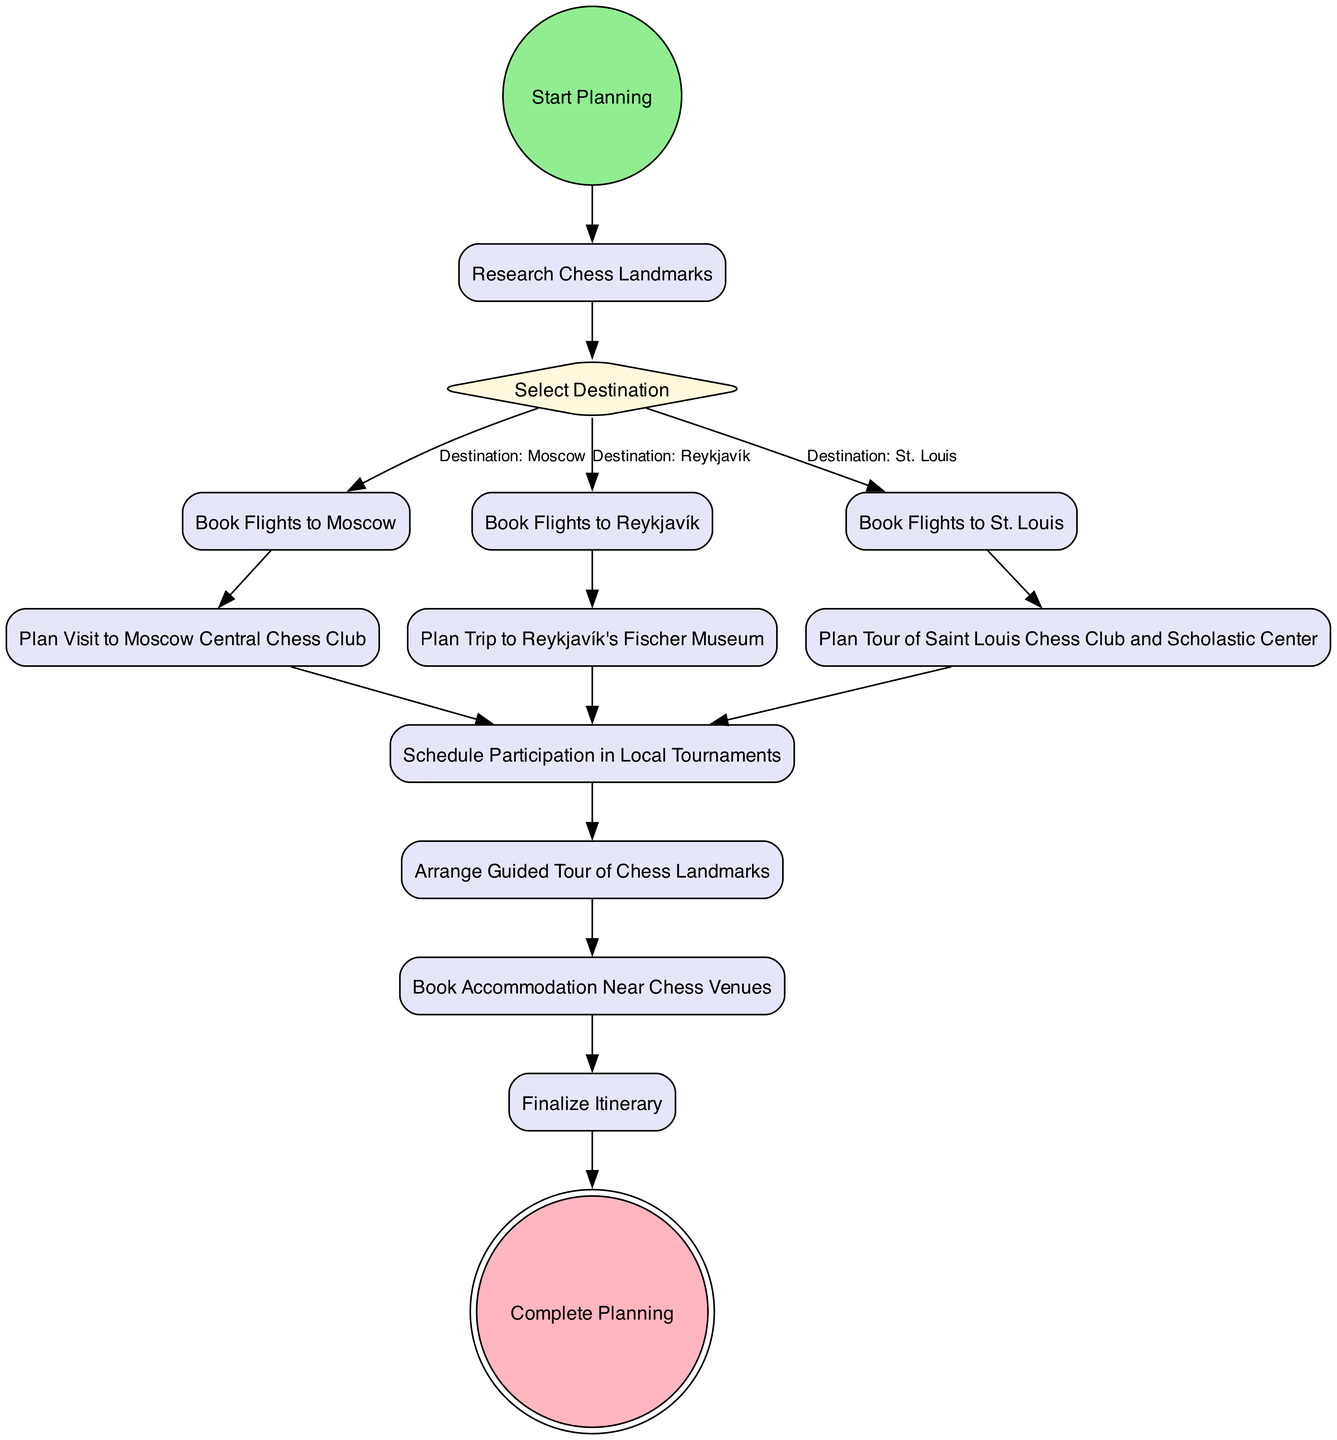What is the first action node in the diagram? The diagram starts with the "Start Planning" node, which leads into the first action, "Research Chess Landmarks."
Answer: Research Chess Landmarks How many decision nodes are in the diagram? There is one decision node, labeled "Select Destination." This node branches into three possible flight destinations.
Answer: 1 What are the three possible destinations listed in the diagram? The three destinations are Moscow, Reykjavík, and St. Louis, each of which has corresponding flight booking actions.
Answer: Moscow, Reykjavík, St. Louis What is the last action before completing the planning? The last action that occurs before reaching the "Complete Planning" node is "Finalize Itinerary."
Answer: Finalize Itinerary Which node requires participation in local tournaments? The node labeled "Schedule Participation in Local Tournaments" requires involvement in local chess tournaments, and it connects to various action nodes beforehand.
Answer: Schedule Participation in Local Tournaments How many total nodes are present in the diagram? By counting all nodes, there are 14, including start, action, decision, and end nodes.
Answer: 14 What type of node is "Book Flights to Reykjavík"? "Book Flights to Reykjavík" is an action node, as it represents a task performed in the planning process.
Answer: action What comes after "Plan Visit to Moscow Central Chess Club"? The next step after "Plan Visit to Moscow Central Chess Club" is "Schedule Participation in Local Tournaments."
Answer: Schedule Participation in Local Tournaments If the destination selected is St. Louis, what is the next action taken? After selecting St. Louis as the destination, the next action taken is to "Plan Tour of Saint Louis Chess Club and Scholastic Center."
Answer: Plan Tour of Saint Louis Chess Club and Scholastic Center 